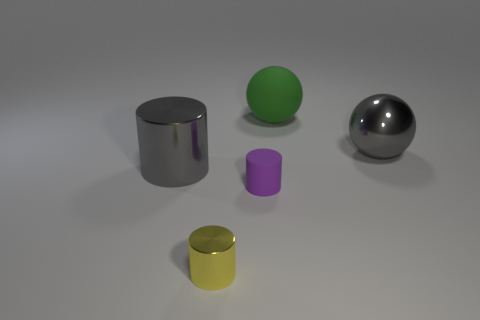Subtract all small purple rubber cylinders. How many cylinders are left? 2 Add 1 large gray metallic balls. How many objects exist? 6 Subtract all yellow cylinders. How many cylinders are left? 2 Subtract all yellow balls. Subtract all brown cubes. How many balls are left? 2 Subtract all gray spheres. How many yellow cylinders are left? 1 Subtract all big purple shiny spheres. Subtract all purple cylinders. How many objects are left? 4 Add 1 gray metal spheres. How many gray metal spheres are left? 2 Add 5 large gray shiny spheres. How many large gray shiny spheres exist? 6 Subtract 0 blue cylinders. How many objects are left? 5 Subtract all balls. How many objects are left? 3 